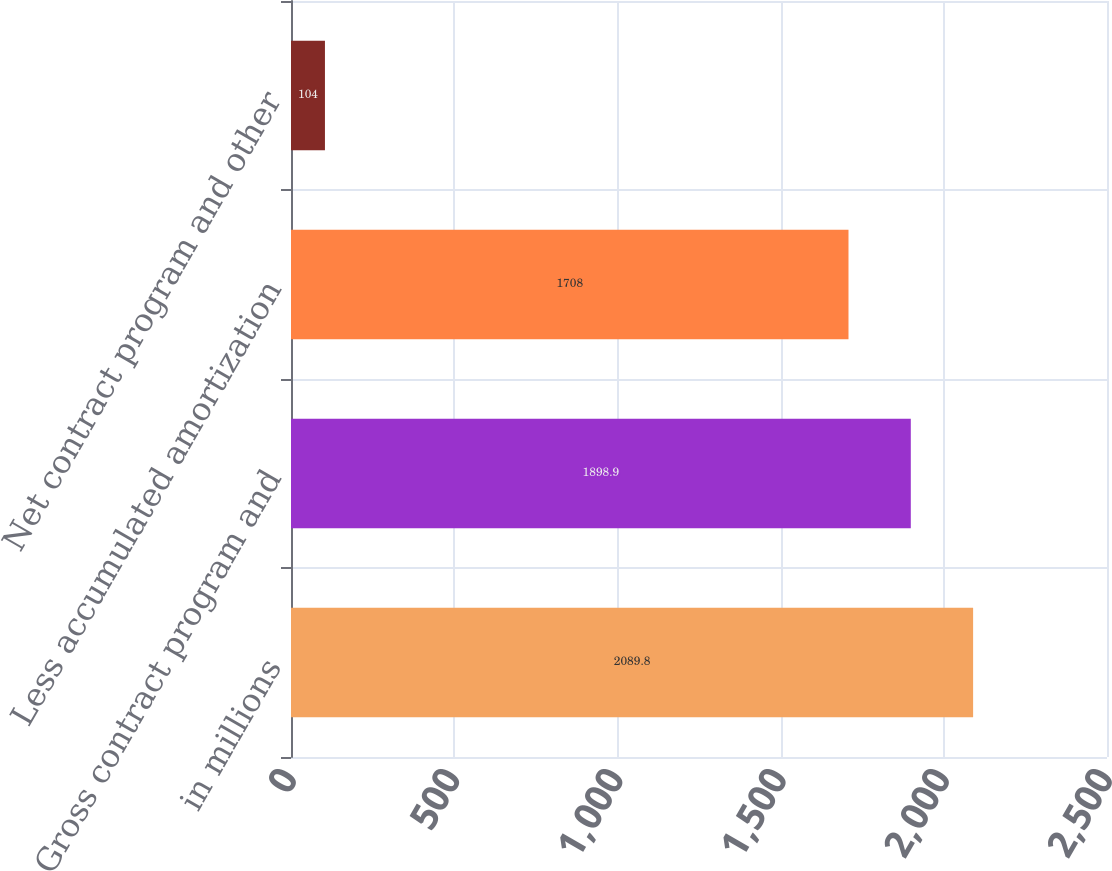Convert chart. <chart><loc_0><loc_0><loc_500><loc_500><bar_chart><fcel>in millions<fcel>Gross contract program and<fcel>Less accumulated amortization<fcel>Net contract program and other<nl><fcel>2089.8<fcel>1898.9<fcel>1708<fcel>104<nl></chart> 